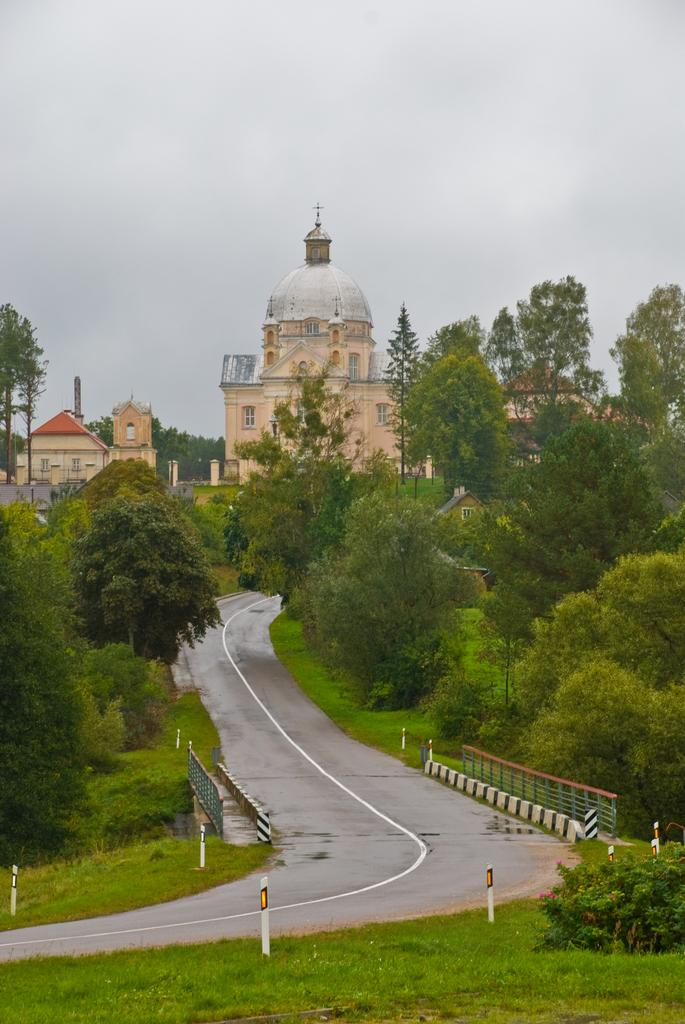What type of surface can be seen in the image? There is a road in the image. What structures are present alongside the road? There are poles in the image. What type of vegetation is visible in the image? There is grass and trees in the image. What type of structures can be seen in the background? There are buildings with windows in the image. What is visible in the sky in the background of the image? The sky is visible in the background of the image, and clouds are present. How many clocks are hanging from the trees in the image? There are no clocks hanging from the trees in the image. What type of humor can be seen in the cemetery in the image? There is no cemetery present in the image, so it is not possible to determine the type of humor. 